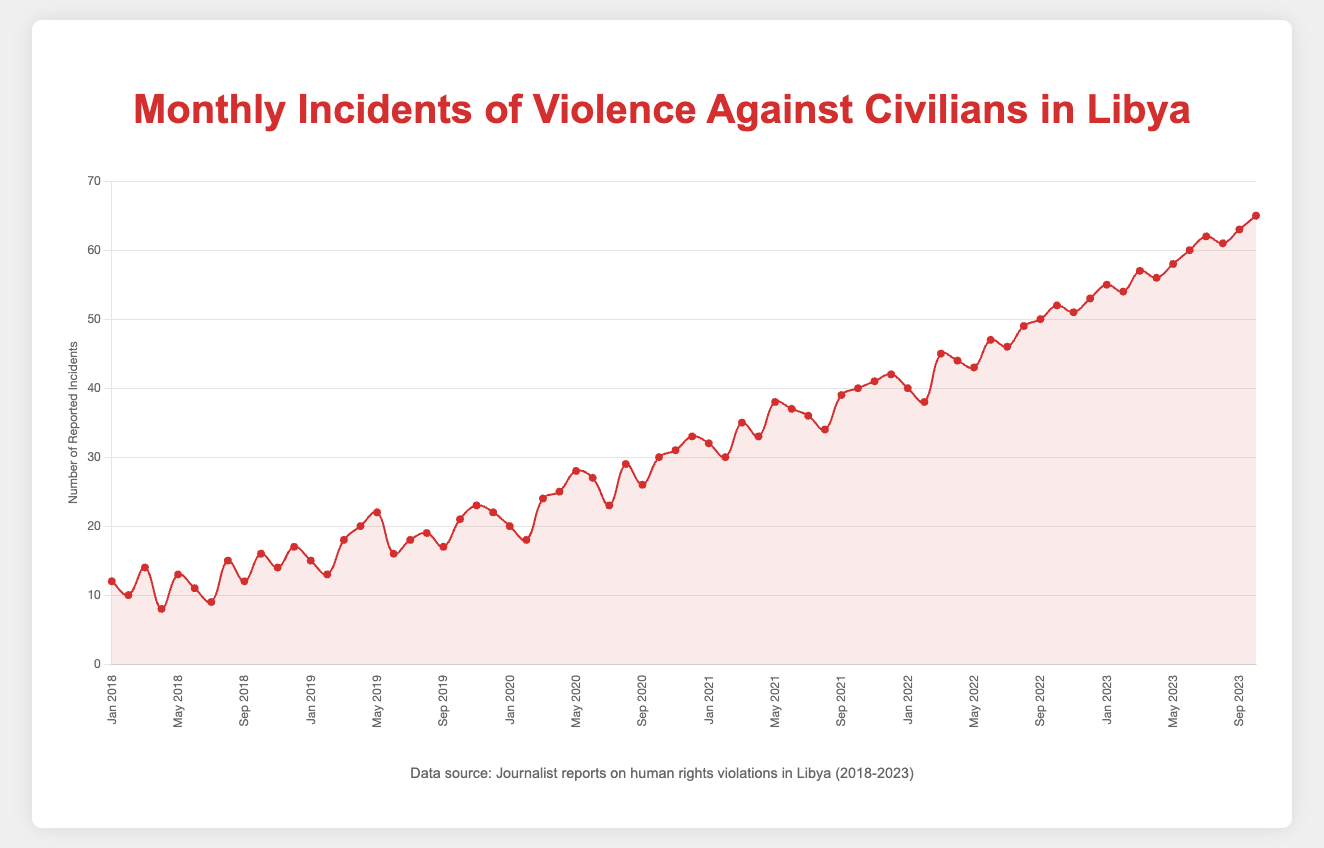What is the trend in the reported incidents of violence against civilians from January 2018 to October 2023? The trend can be seen by examining the overall direction of the line plot. The number of reported incidents increases consistently from January 2018 (with 12 incidents) to October 2023 (with 65 incidents), indicating a rising trend in incidents of violence against civilians over this period.
Answer: Rising trend Which month saw the highest number of reported incidents in the year 2020? To determine the highest number of incidents in 2020, check the data points for each month in 2020. December 2020 shows the highest number of reported incidents with 33.
Answer: December 2020 By how much did the reported incidents increase from January 2019 to December 2019? Calculate the difference between the reported incidents in January 2019 (15 incidents) and December 2019 (22 incidents): 22 - 15 = 7.
Answer: 7 Compare the reported incidents in June 2018 and June 2023. Which month had fewer incidents, and by how much? June 2018 had 11 incidents, and June 2023 had 60 incidents. The difference is 60 - 11 = 49. June 2018 had fewer incidents by 49.
Answer: June 2018, by 49 On average, how many incidents were reported per month in the year 2021? Add the reported incidents for each month in 2021 and divide by the number of months: (32 + 30 + 35 + 33 + 38 + 37 + 36 + 34 + 39 + 40 + 41 + 42) / 12 = 37.25.
Answer: 37.25 What is the difference between the lowest and the highest reported incidents in the entire dataset? The lowest reported incidents are 8 (April 2018) and the highest are 65 (October 2023). The difference is 65 - 8 = 57.
Answer: 57 In which year did the incidents increase the most rapidly, and what was the approximate increase rate per month for that year? Compare the year-to-year data to find the steepest increase. 2020 saw a significant rise from 22 incidents in December 2019 to 33 incidents in December 2020. The increase per month for 2020 is approximately (33 - 22) / 12 ≈ 0.92 incidents/month.
Answer: 2020, approximate increase rate of 0.92 incidents/month 